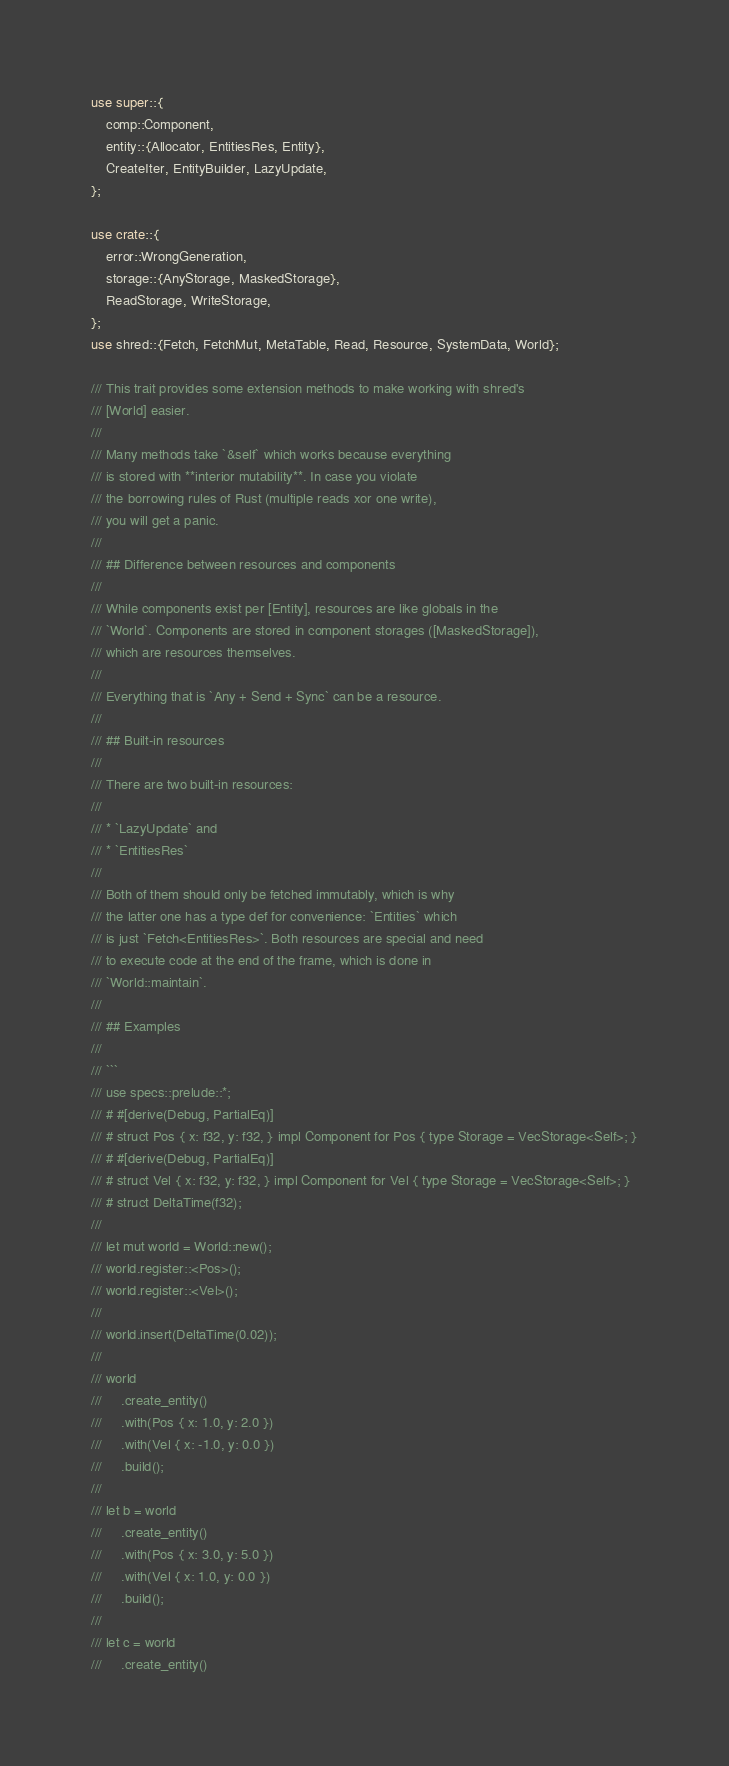<code> <loc_0><loc_0><loc_500><loc_500><_Rust_>use super::{
    comp::Component,
    entity::{Allocator, EntitiesRes, Entity},
    CreateIter, EntityBuilder, LazyUpdate,
};

use crate::{
    error::WrongGeneration,
    storage::{AnyStorage, MaskedStorage},
    ReadStorage, WriteStorage,
};
use shred::{Fetch, FetchMut, MetaTable, Read, Resource, SystemData, World};

/// This trait provides some extension methods to make working with shred's
/// [World] easier.
///
/// Many methods take `&self` which works because everything
/// is stored with **interior mutability**. In case you violate
/// the borrowing rules of Rust (multiple reads xor one write),
/// you will get a panic.
///
/// ## Difference between resources and components
///
/// While components exist per [Entity], resources are like globals in the
/// `World`. Components are stored in component storages ([MaskedStorage]),
/// which are resources themselves.
///
/// Everything that is `Any + Send + Sync` can be a resource.
///
/// ## Built-in resources
///
/// There are two built-in resources:
///
/// * `LazyUpdate` and
/// * `EntitiesRes`
///
/// Both of them should only be fetched immutably, which is why
/// the latter one has a type def for convenience: `Entities` which
/// is just `Fetch<EntitiesRes>`. Both resources are special and need
/// to execute code at the end of the frame, which is done in
/// `World::maintain`.
///
/// ## Examples
///
/// ```
/// use specs::prelude::*;
/// # #[derive(Debug, PartialEq)]
/// # struct Pos { x: f32, y: f32, } impl Component for Pos { type Storage = VecStorage<Self>; }
/// # #[derive(Debug, PartialEq)]
/// # struct Vel { x: f32, y: f32, } impl Component for Vel { type Storage = VecStorage<Self>; }
/// # struct DeltaTime(f32);
///
/// let mut world = World::new();
/// world.register::<Pos>();
/// world.register::<Vel>();
///
/// world.insert(DeltaTime(0.02));
///
/// world
///     .create_entity()
///     .with(Pos { x: 1.0, y: 2.0 })
///     .with(Vel { x: -1.0, y: 0.0 })
///     .build();
///
/// let b = world
///     .create_entity()
///     .with(Pos { x: 3.0, y: 5.0 })
///     .with(Vel { x: 1.0, y: 0.0 })
///     .build();
///
/// let c = world
///     .create_entity()</code> 